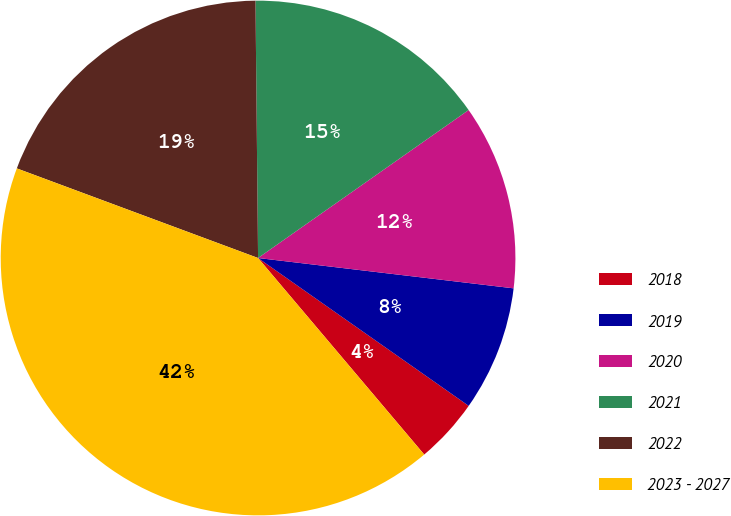<chart> <loc_0><loc_0><loc_500><loc_500><pie_chart><fcel>2018<fcel>2019<fcel>2020<fcel>2021<fcel>2022<fcel>2023 - 2027<nl><fcel>4.09%<fcel>7.86%<fcel>11.63%<fcel>15.41%<fcel>19.18%<fcel>41.83%<nl></chart> 